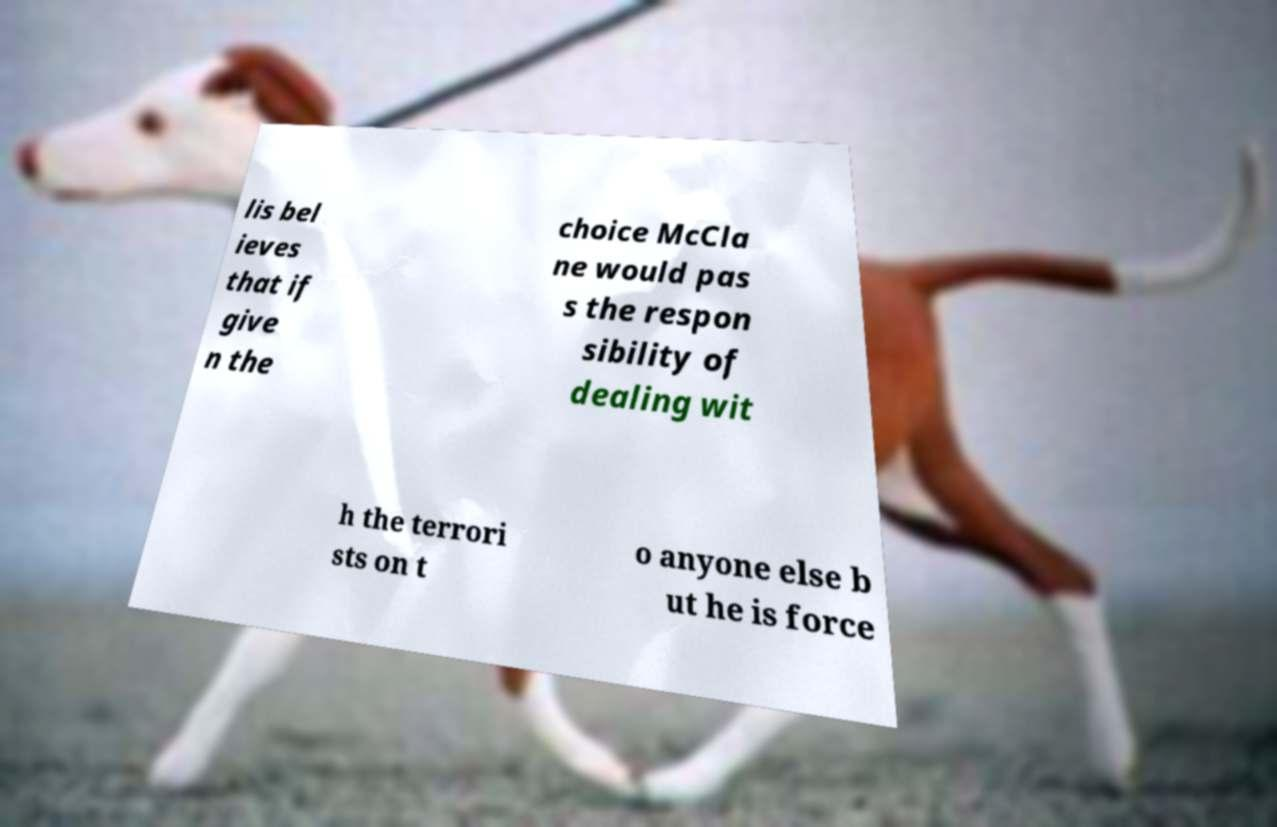Could you extract and type out the text from this image? lis bel ieves that if give n the choice McCla ne would pas s the respon sibility of dealing wit h the terrori sts on t o anyone else b ut he is force 